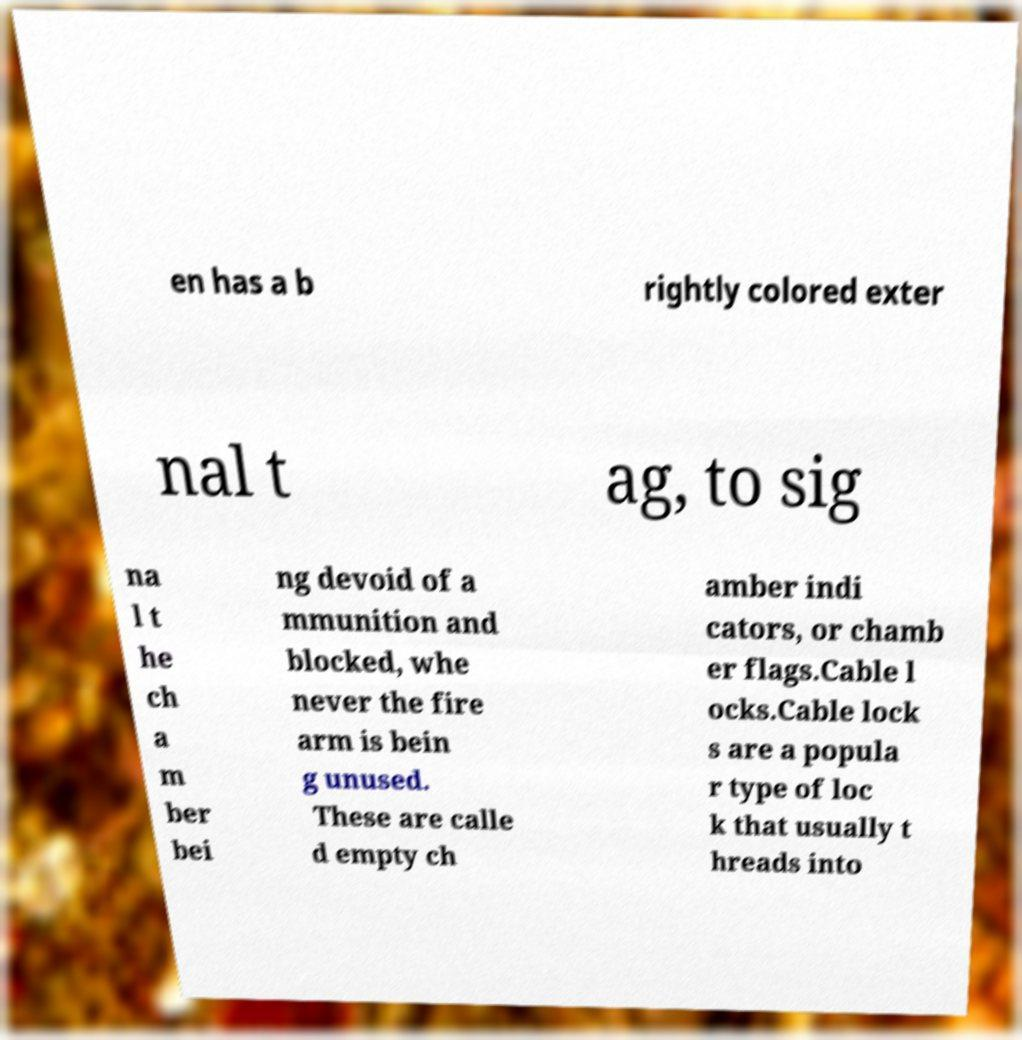For documentation purposes, I need the text within this image transcribed. Could you provide that? en has a b rightly colored exter nal t ag, to sig na l t he ch a m ber bei ng devoid of a mmunition and blocked, whe never the fire arm is bein g unused. These are calle d empty ch amber indi cators, or chamb er flags.Cable l ocks.Cable lock s are a popula r type of loc k that usually t hreads into 